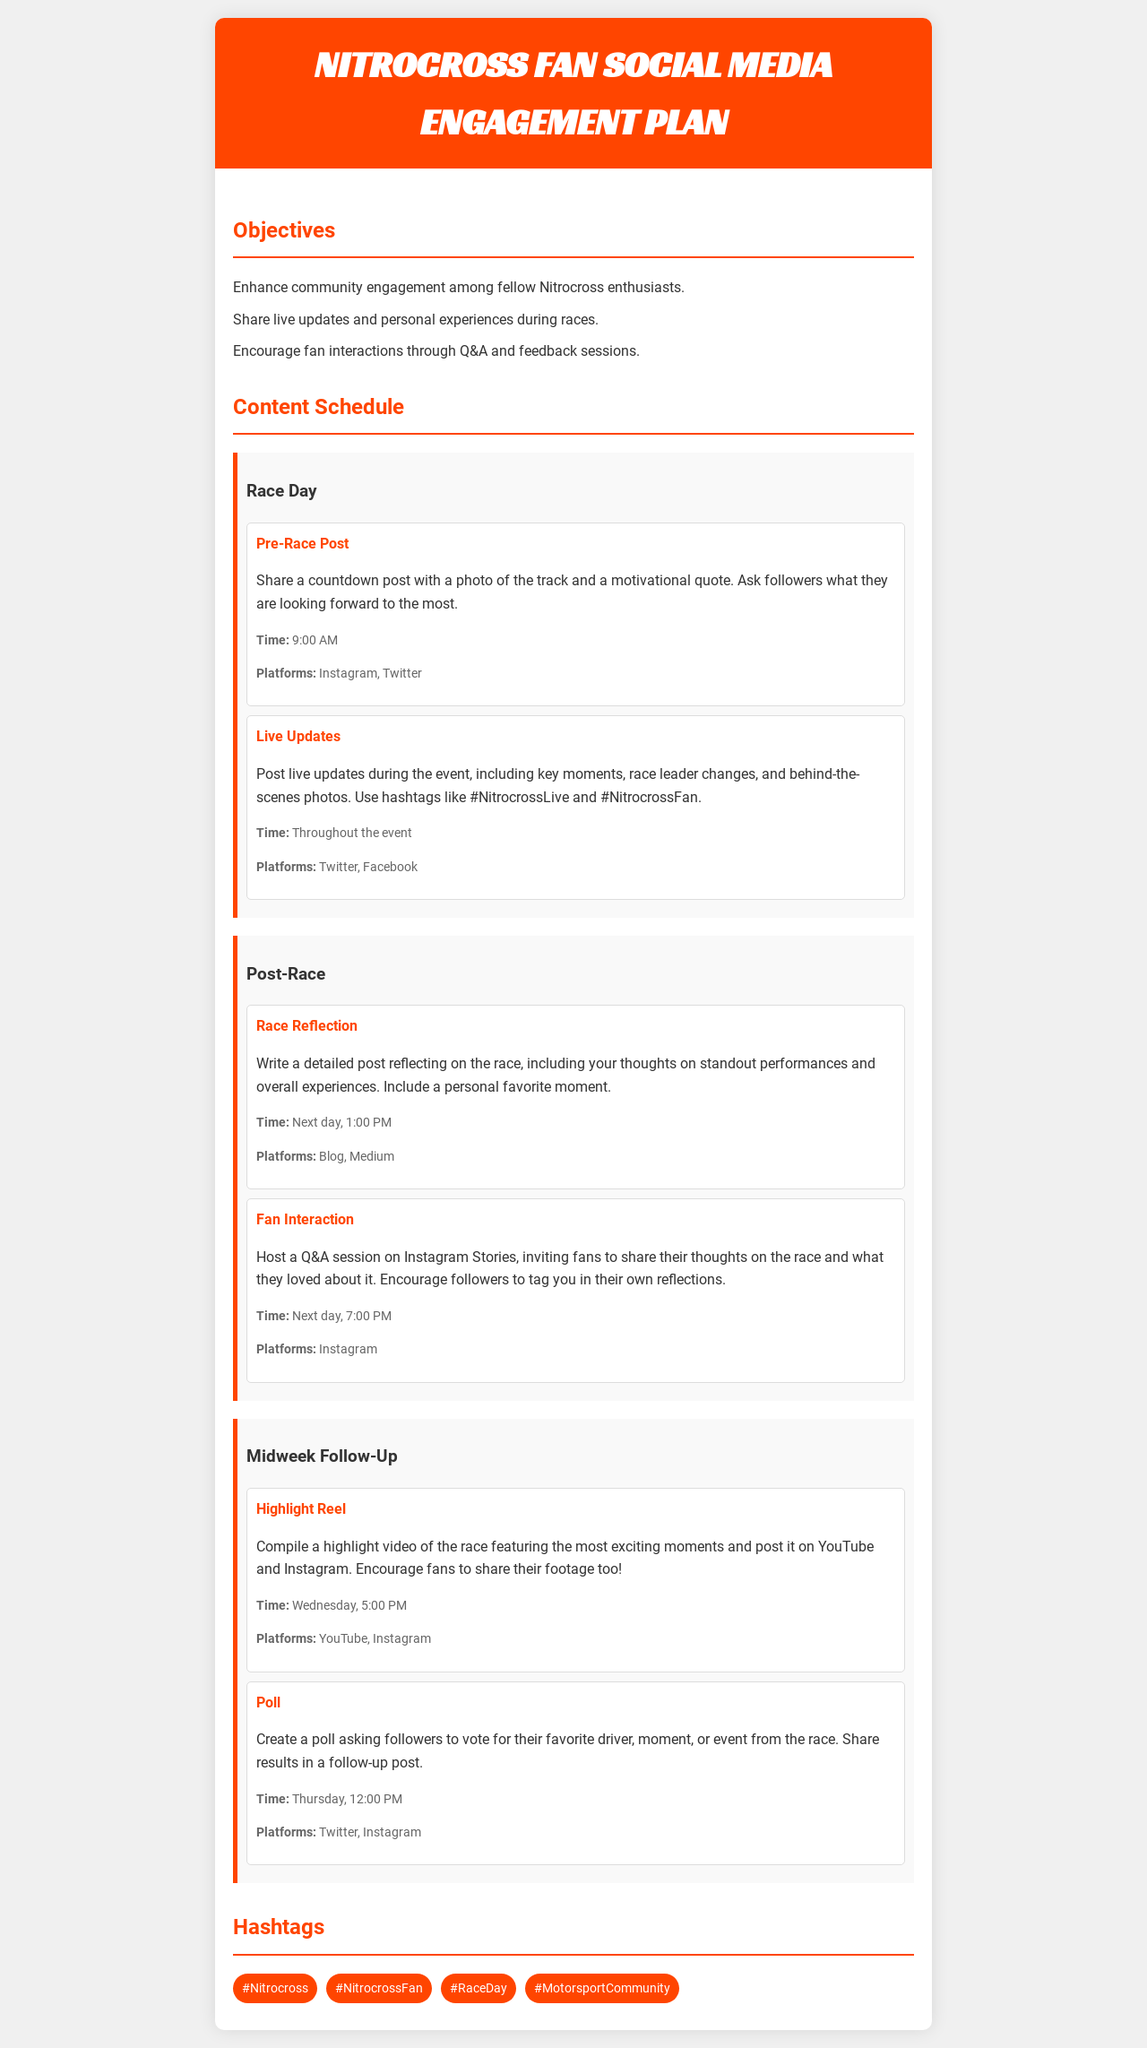what is the main objective of the engagement plan? The main objective of the engagement plan includes enhancing community engagement among fellow Nitrocross enthusiasts.
Answer: Enhance community engagement when is the Pre-Race Post scheduled? The Pre-Race Post is scheduled at 9:00 AM on Race Day.
Answer: 9:00 AM which platforms are used for Live Updates? The platforms for Live Updates during the event are Twitter and Facebook.
Answer: Twitter, Facebook what activity comes after the Race Reflection? The activity that comes after the Race Reflection is the Fan Interaction session.
Answer: Fan Interaction what time is the Highlight Reel scheduled for posting? The Highlight Reel is scheduled for posting on Wednesday at 5:00 PM.
Answer: 5:00 PM how many hashtags are listed in the document? The document lists four hashtags for engagement.
Answer: Four what type of content is shared during the Live Updates? The content shared during the Live Updates includes key moments, race leader changes, and behind-the-scenes photos.
Answer: Key moments, race leader changes, behind-the-scenes photos what day does the Poll activity occur? The Poll activity occurs on Thursday.
Answer: Thursday 